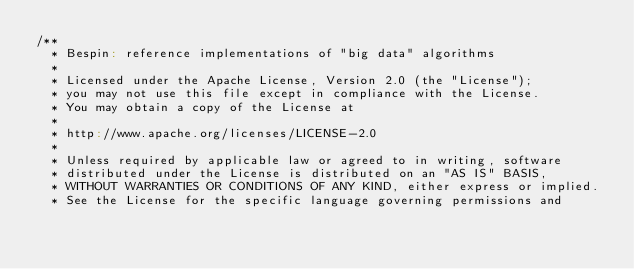<code> <loc_0><loc_0><loc_500><loc_500><_Scala_>/**
  * Bespin: reference implementations of "big data" algorithms
  *
  * Licensed under the Apache License, Version 2.0 (the "License");
  * you may not use this file except in compliance with the License.
  * You may obtain a copy of the License at
  *
  * http://www.apache.org/licenses/LICENSE-2.0
  *
  * Unless required by applicable law or agreed to in writing, software
  * distributed under the License is distributed on an "AS IS" BASIS,
  * WITHOUT WARRANTIES OR CONDITIONS OF ANY KIND, either express or implied.
  * See the License for the specific language governing permissions and</code> 